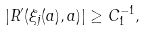<formula> <loc_0><loc_0><loc_500><loc_500>| R ^ { \prime } ( \xi _ { j } ( a ) , a ) | \geq C _ { 1 } ^ { - 1 } ,</formula> 